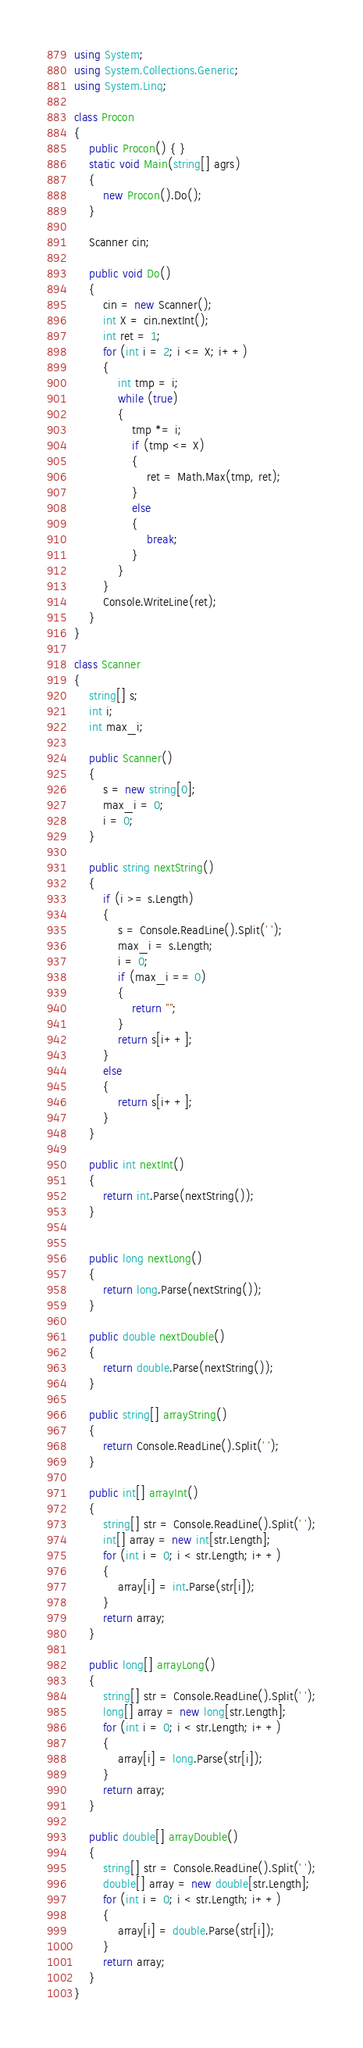Convert code to text. <code><loc_0><loc_0><loc_500><loc_500><_C#_>using System;
using System.Collections.Generic;
using System.Linq;

class Procon
{
    public Procon() { }
    static void Main(string[] agrs)
    {
        new Procon().Do();
    }

    Scanner cin;

    public void Do()
    {
        cin = new Scanner();
        int X = cin.nextInt();
        int ret = 1;
        for (int i = 2; i <= X; i++)
        {
            int tmp = i;
            while (true)
            {
                tmp *= i;
                if (tmp <= X)
                {
                    ret = Math.Max(tmp, ret);
                }
                else
                {
                    break;
                }
            }
        }
        Console.WriteLine(ret);
    }
}

class Scanner
{
    string[] s;
    int i;
    int max_i;

    public Scanner()
    {
        s = new string[0];
        max_i = 0;
        i = 0;
    }

    public string nextString()
    {
        if (i >= s.Length)
        {
            s = Console.ReadLine().Split(' ');
            max_i = s.Length;
            i = 0;
            if (max_i == 0)
            {
                return "";
            }
            return s[i++];
        }
        else
        {
            return s[i++];
        }
    }

    public int nextInt()
    {
        return int.Parse(nextString());
    }


    public long nextLong()
    {
        return long.Parse(nextString());
    }

    public double nextDouble()
    {
        return double.Parse(nextString());
    }

    public string[] arrayString()
    {
        return Console.ReadLine().Split(' ');
    }

    public int[] arrayInt()
    {
        string[] str = Console.ReadLine().Split(' ');
        int[] array = new int[str.Length];
        for (int i = 0; i < str.Length; i++)
        {
            array[i] = int.Parse(str[i]);
        }
        return array;
    }

    public long[] arrayLong()
    {
        string[] str = Console.ReadLine().Split(' ');
        long[] array = new long[str.Length];
        for (int i = 0; i < str.Length; i++)
        {
            array[i] = long.Parse(str[i]);
        }
        return array;
    }

    public double[] arrayDouble()
    {
        string[] str = Console.ReadLine().Split(' ');
        double[] array = new double[str.Length];
        for (int i = 0; i < str.Length; i++)
        {
            array[i] = double.Parse(str[i]);
        }
        return array;
    }
}
</code> 